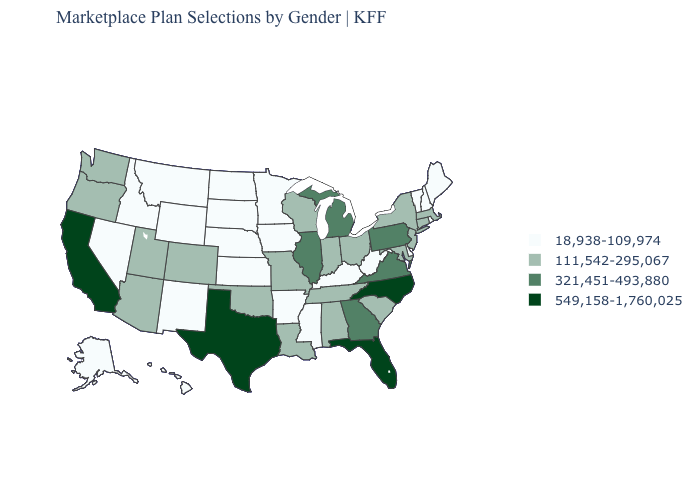Is the legend a continuous bar?
Concise answer only. No. What is the lowest value in states that border Rhode Island?
Short answer required. 111,542-295,067. Among the states that border North Dakota , which have the lowest value?
Keep it brief. Minnesota, Montana, South Dakota. Name the states that have a value in the range 549,158-1,760,025?
Concise answer only. California, Florida, North Carolina, Texas. Which states have the lowest value in the Northeast?
Quick response, please. Maine, New Hampshire, Rhode Island, Vermont. Does Tennessee have the same value as Wyoming?
Answer briefly. No. How many symbols are there in the legend?
Keep it brief. 4. Does California have the highest value in the West?
Concise answer only. Yes. What is the highest value in the Northeast ?
Be succinct. 321,451-493,880. Does Wyoming have the same value as Georgia?
Quick response, please. No. What is the value of Iowa?
Short answer required. 18,938-109,974. Which states have the highest value in the USA?
Quick response, please. California, Florida, North Carolina, Texas. What is the lowest value in the USA?
Answer briefly. 18,938-109,974. Which states have the lowest value in the USA?
Write a very short answer. Alaska, Arkansas, Delaware, Hawaii, Idaho, Iowa, Kansas, Kentucky, Maine, Minnesota, Mississippi, Montana, Nebraska, Nevada, New Hampshire, New Mexico, North Dakota, Rhode Island, South Dakota, Vermont, West Virginia, Wyoming. What is the lowest value in the USA?
Concise answer only. 18,938-109,974. 